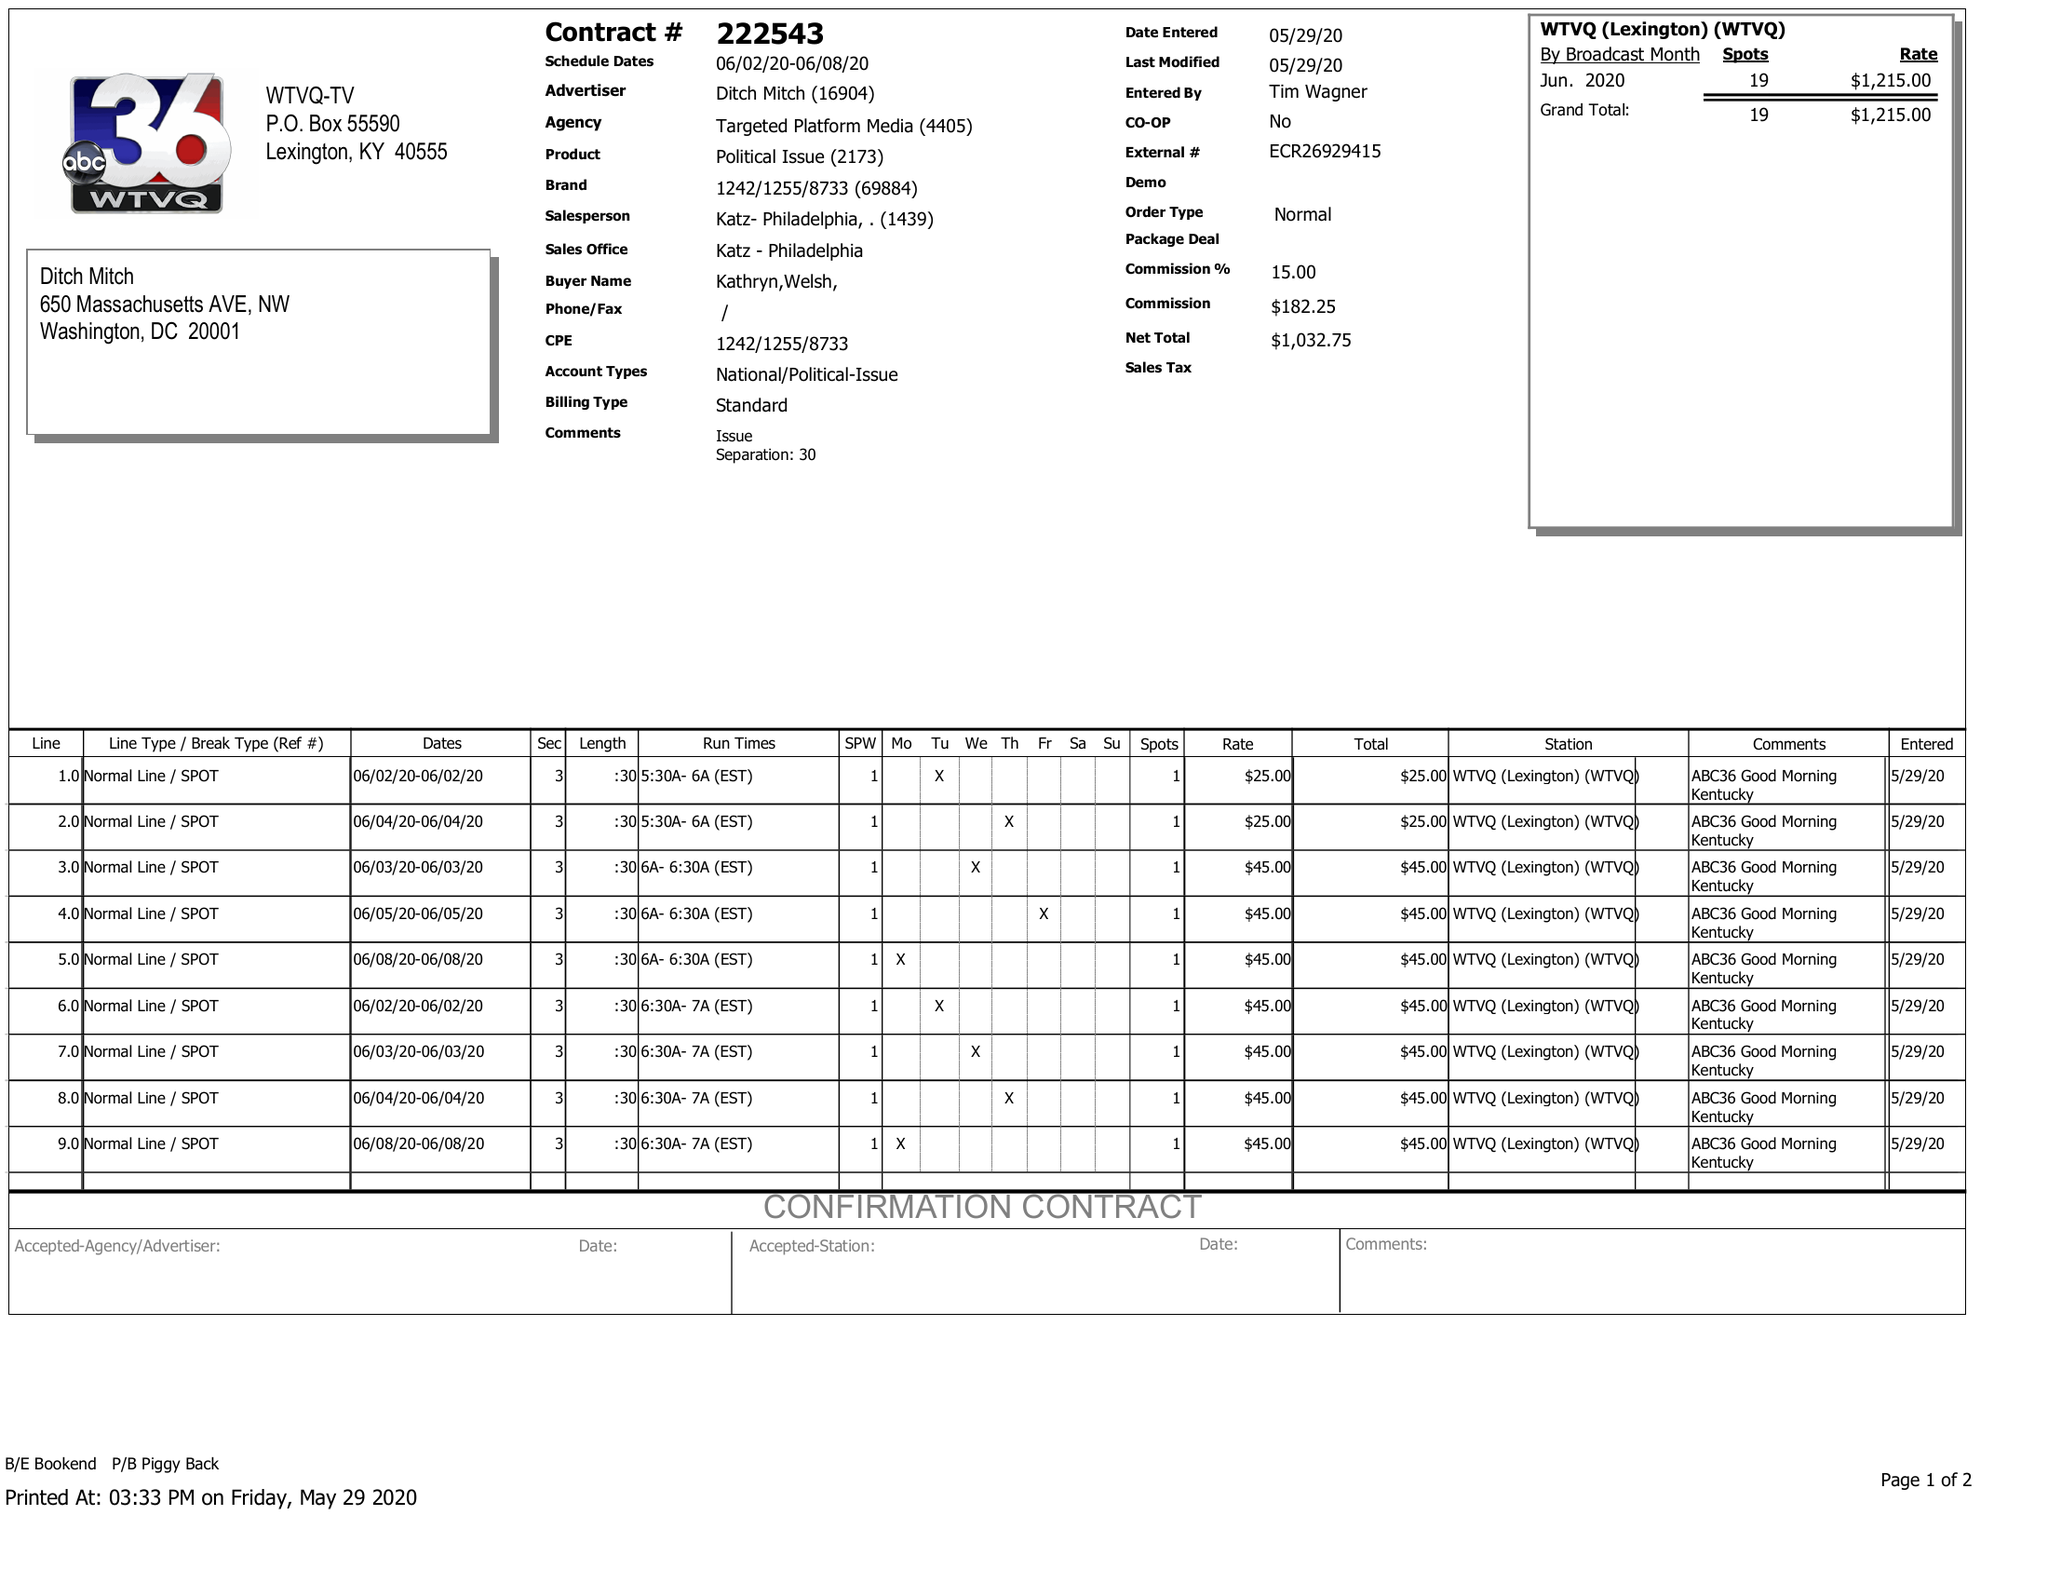What is the value for the gross_amount?
Answer the question using a single word or phrase. 1215.00 